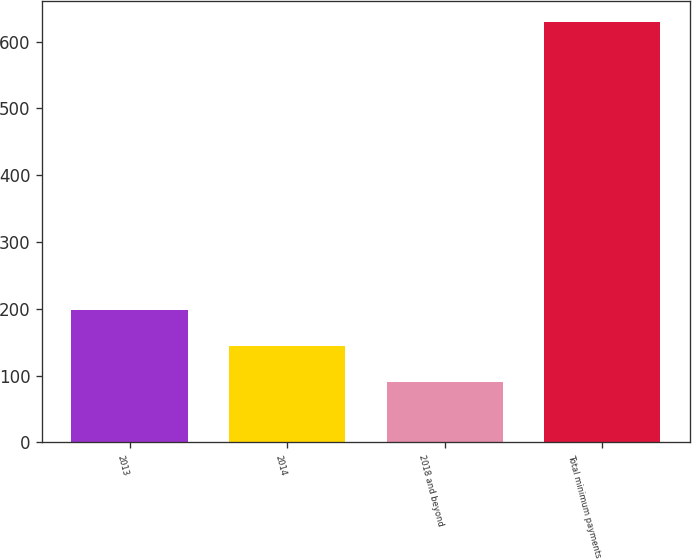Convert chart to OTSL. <chart><loc_0><loc_0><loc_500><loc_500><bar_chart><fcel>2013<fcel>2014<fcel>2018 and beyond<fcel>Total minimum payments<nl><fcel>198.8<fcel>144.9<fcel>91<fcel>630<nl></chart> 